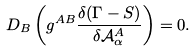<formula> <loc_0><loc_0><loc_500><loc_500>D _ { B } \left ( g ^ { A B } \frac { \delta ( \Gamma - S ) } { \delta \mathcal { A } ^ { A } _ { \alpha } } \right ) = 0 .</formula> 